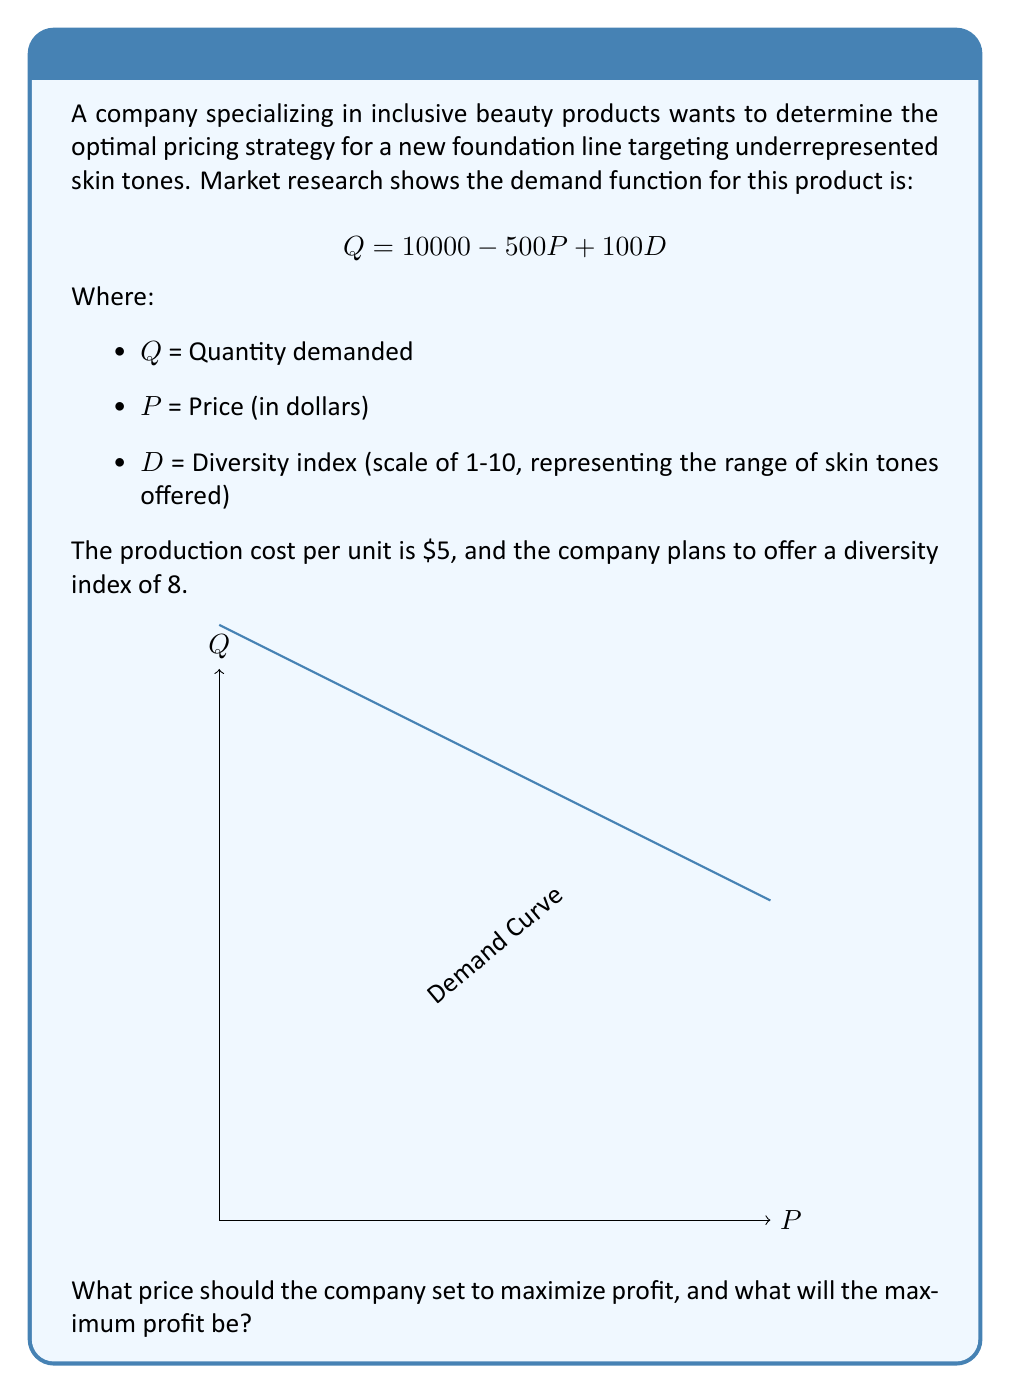Can you answer this question? Let's approach this step-by-step:

1) First, we need to formulate the profit function. Profit is revenue minus cost:
   $$\text{Profit} = \text{Revenue} - \text{Cost}$$

2) Revenue is price times quantity: $PQ$
   Cost is the per-unit cost times quantity: $5Q$

3) Substituting the demand function and simplifying:
   $$\text{Profit} = P(10000 - 500P + 100D) - 5(10000 - 500P + 100D)$$
   $$= 10000P - 500P^2 + 100DP - 50000 + 2500P - 500D$$
   $$= -500P^2 + (12500 + 100D)P - (50000 + 500D)$$

4) We know $D = 8$, so let's substitute that:
   $$\text{Profit} = -500P^2 + 13300P - 54000$$

5) To find the maximum profit, we need to find where the derivative of this function equals zero:
   $$\frac{d(\text{Profit})}{dP} = -1000P + 13300 = 0$$

6) Solving for P:
   $$-1000P = -13300$$
   $$P = 13.30$$

7) To confirm this is a maximum, we can check that the second derivative is negative:
   $$\frac{d^2(\text{Profit})}{dP^2} = -1000 < 0$$

8) Now we can calculate the maximum profit by substituting $P = 13.30$ into our profit function:
   $$\text{Max Profit} = -500(13.30)^2 + 13300(13.30) - 54000$$
   $$= -88445 + 176890 - 54000$$
   $$= 34445$$

Therefore, the optimal price is $\$13.30$, and the maximum profit is $\$34,445$.
Answer: Optimal price: $\$13.30$; Maximum profit: $\$34,445$ 